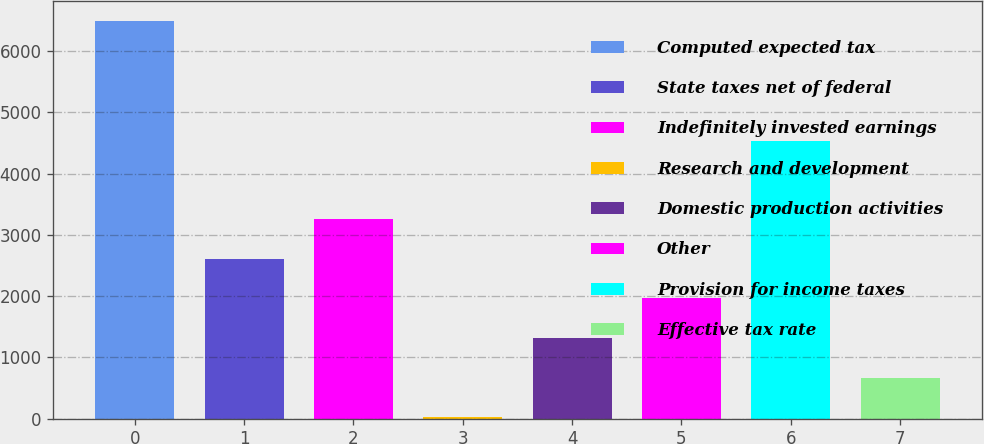Convert chart. <chart><loc_0><loc_0><loc_500><loc_500><bar_chart><fcel>Computed expected tax<fcel>State taxes net of federal<fcel>Indefinitely invested earnings<fcel>Research and development<fcel>Domestic production activities<fcel>Other<fcel>Provision for income taxes<fcel>Effective tax rate<nl><fcel>6489<fcel>2609.4<fcel>3256<fcel>23<fcel>1316.2<fcel>1962.8<fcel>4527<fcel>669.6<nl></chart> 